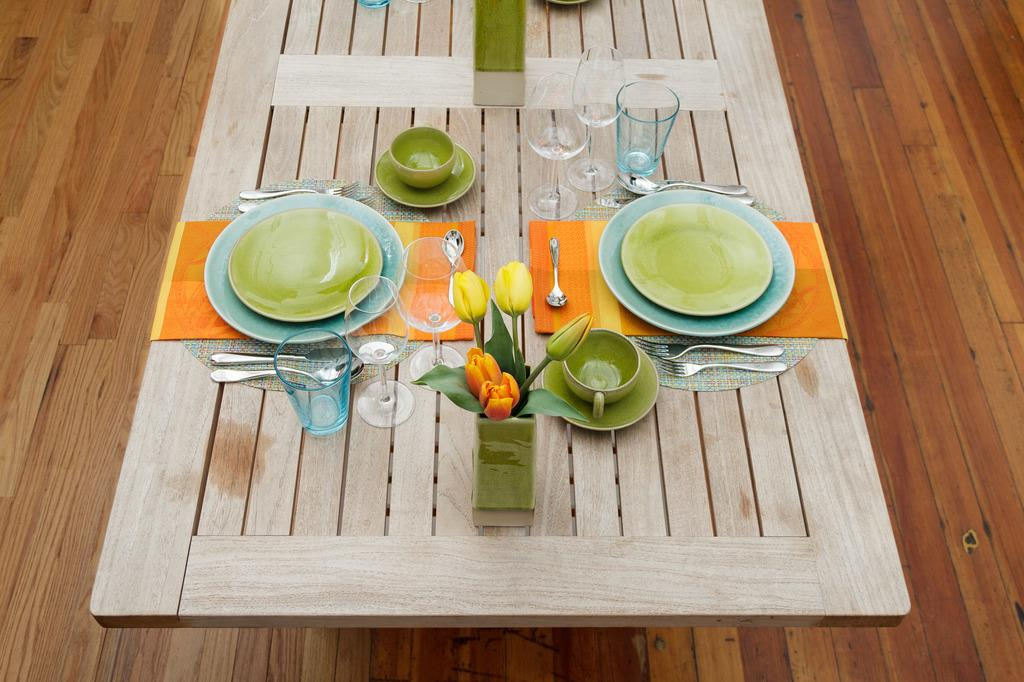What objects are on the table in the image? Empty plates, spoons, forks, a tulip flower vase, water glasses, a cup, and a saucer are on the table in the image. What type of utensils can be seen in the image? Spoons and forks are visible in the image. What is the purpose of the tulip flower vase in the image? The tulip flower vase is likely used for holding flowers, although there are no flowers present in the image. What type of glassware is visible in the image? Water glasses are in the image. What is the cup placed on in the image? The cup is placed on a saucer. What part of the room can be seen in the image? The table and the floor are visible in the image. How many zippers can be seen on the empty plates in the image? There are no zippers present on the empty plates in the image. What type of orange fruit is visible on the table in the image? There is no orange fruit present on the table in the image. 